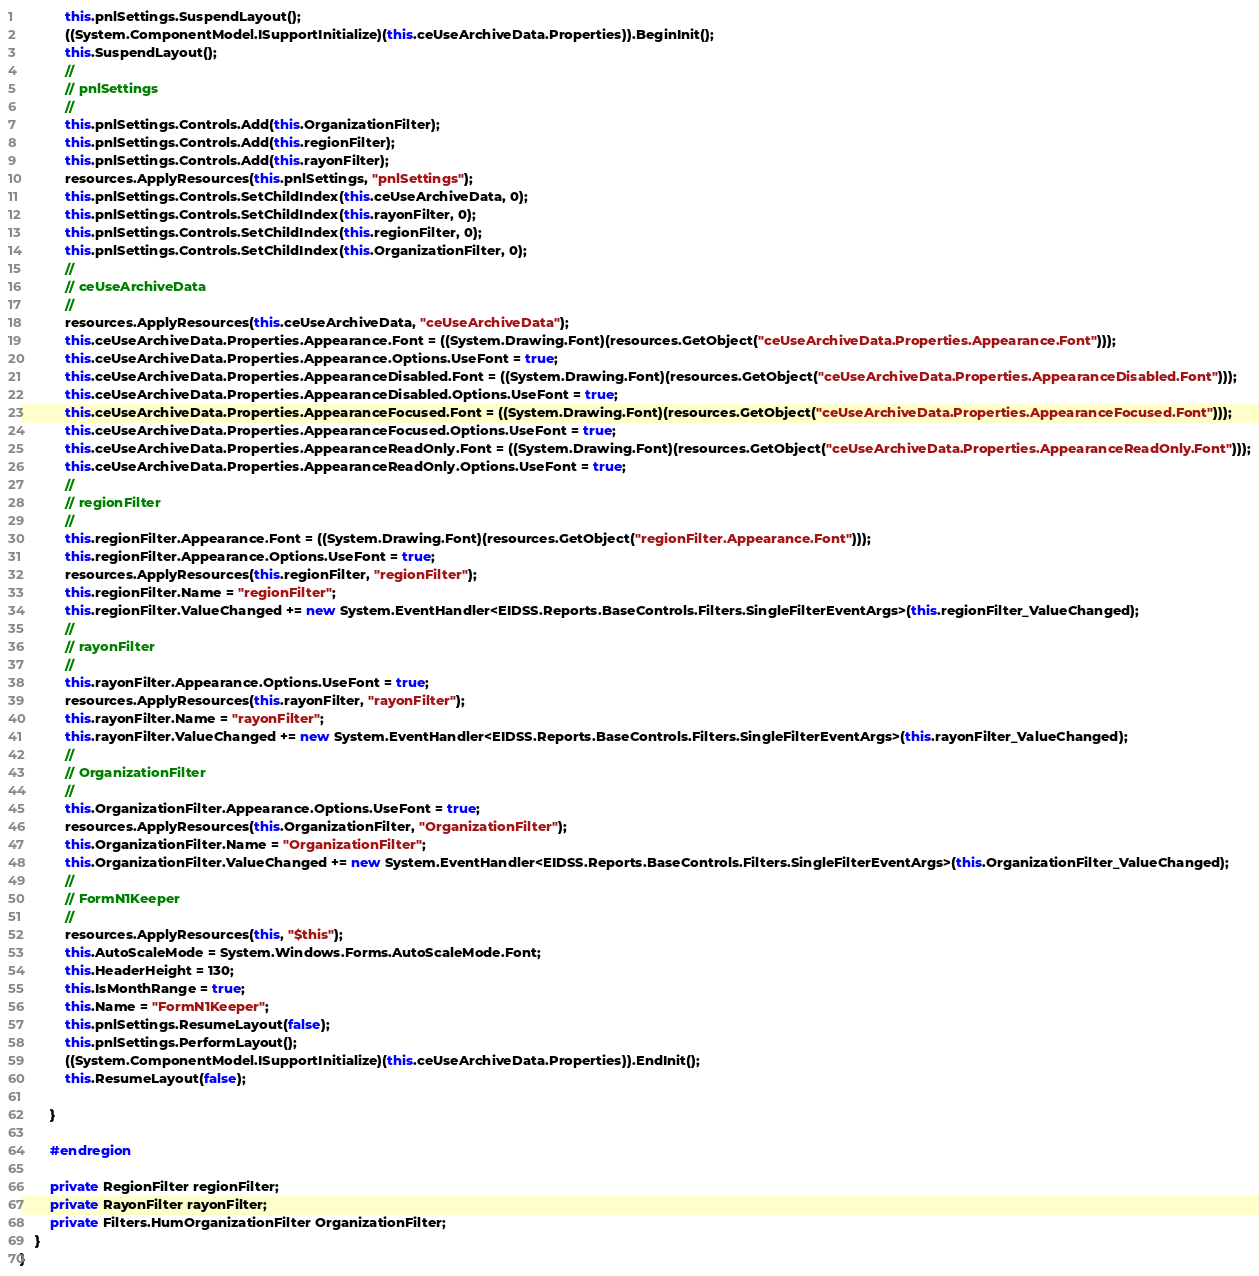<code> <loc_0><loc_0><loc_500><loc_500><_C#_>            this.pnlSettings.SuspendLayout();
            ((System.ComponentModel.ISupportInitialize)(this.ceUseArchiveData.Properties)).BeginInit();
            this.SuspendLayout();
            // 
            // pnlSettings
            // 
            this.pnlSettings.Controls.Add(this.OrganizationFilter);
            this.pnlSettings.Controls.Add(this.regionFilter);
            this.pnlSettings.Controls.Add(this.rayonFilter);
            resources.ApplyResources(this.pnlSettings, "pnlSettings");
            this.pnlSettings.Controls.SetChildIndex(this.ceUseArchiveData, 0);
            this.pnlSettings.Controls.SetChildIndex(this.rayonFilter, 0);
            this.pnlSettings.Controls.SetChildIndex(this.regionFilter, 0);
            this.pnlSettings.Controls.SetChildIndex(this.OrganizationFilter, 0);
            // 
            // ceUseArchiveData
            // 
            resources.ApplyResources(this.ceUseArchiveData, "ceUseArchiveData");
            this.ceUseArchiveData.Properties.Appearance.Font = ((System.Drawing.Font)(resources.GetObject("ceUseArchiveData.Properties.Appearance.Font")));
            this.ceUseArchiveData.Properties.Appearance.Options.UseFont = true;
            this.ceUseArchiveData.Properties.AppearanceDisabled.Font = ((System.Drawing.Font)(resources.GetObject("ceUseArchiveData.Properties.AppearanceDisabled.Font")));
            this.ceUseArchiveData.Properties.AppearanceDisabled.Options.UseFont = true;
            this.ceUseArchiveData.Properties.AppearanceFocused.Font = ((System.Drawing.Font)(resources.GetObject("ceUseArchiveData.Properties.AppearanceFocused.Font")));
            this.ceUseArchiveData.Properties.AppearanceFocused.Options.UseFont = true;
            this.ceUseArchiveData.Properties.AppearanceReadOnly.Font = ((System.Drawing.Font)(resources.GetObject("ceUseArchiveData.Properties.AppearanceReadOnly.Font")));
            this.ceUseArchiveData.Properties.AppearanceReadOnly.Options.UseFont = true;
            // 
            // regionFilter
            // 
            this.regionFilter.Appearance.Font = ((System.Drawing.Font)(resources.GetObject("regionFilter.Appearance.Font")));
            this.regionFilter.Appearance.Options.UseFont = true;
            resources.ApplyResources(this.regionFilter, "regionFilter");
            this.regionFilter.Name = "regionFilter";
            this.regionFilter.ValueChanged += new System.EventHandler<EIDSS.Reports.BaseControls.Filters.SingleFilterEventArgs>(this.regionFilter_ValueChanged);
            // 
            // rayonFilter
            // 
            this.rayonFilter.Appearance.Options.UseFont = true;
            resources.ApplyResources(this.rayonFilter, "rayonFilter");
            this.rayonFilter.Name = "rayonFilter";
            this.rayonFilter.ValueChanged += new System.EventHandler<EIDSS.Reports.BaseControls.Filters.SingleFilterEventArgs>(this.rayonFilter_ValueChanged);
            // 
            // OrganizationFilter
            // 
            this.OrganizationFilter.Appearance.Options.UseFont = true;
            resources.ApplyResources(this.OrganizationFilter, "OrganizationFilter");
            this.OrganizationFilter.Name = "OrganizationFilter";
            this.OrganizationFilter.ValueChanged += new System.EventHandler<EIDSS.Reports.BaseControls.Filters.SingleFilterEventArgs>(this.OrganizationFilter_ValueChanged);
            // 
            // FormN1Keeper
            // 
            resources.ApplyResources(this, "$this");
            this.AutoScaleMode = System.Windows.Forms.AutoScaleMode.Font;
            this.HeaderHeight = 130;
            this.IsMonthRange = true;
            this.Name = "FormN1Keeper";
            this.pnlSettings.ResumeLayout(false);
            this.pnlSettings.PerformLayout();
            ((System.ComponentModel.ISupportInitialize)(this.ceUseArchiveData.Properties)).EndInit();
            this.ResumeLayout(false);

        }

        #endregion

        private RegionFilter regionFilter;
        private RayonFilter rayonFilter;
        private Filters.HumOrganizationFilter OrganizationFilter;
    }
}
</code> 